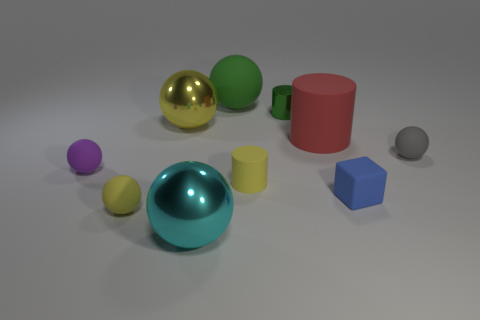Subtract all green balls. How many balls are left? 5 Subtract all tiny cylinders. How many cylinders are left? 1 Subtract 2 balls. How many balls are left? 4 Subtract all purple spheres. Subtract all blue cylinders. How many spheres are left? 5 Subtract all spheres. How many objects are left? 4 Add 3 purple cylinders. How many purple cylinders exist? 3 Subtract 0 purple cylinders. How many objects are left? 10 Subtract all large yellow shiny cubes. Subtract all small blue cubes. How many objects are left? 9 Add 7 large cyan metal things. How many large cyan metal things are left? 8 